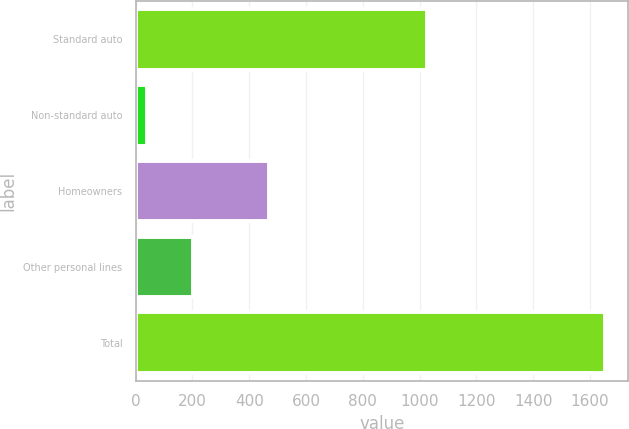Convert chart. <chart><loc_0><loc_0><loc_500><loc_500><bar_chart><fcel>Standard auto<fcel>Non-standard auto<fcel>Homeowners<fcel>Other personal lines<fcel>Total<nl><fcel>1025<fcel>40<fcel>471<fcel>201.1<fcel>1651<nl></chart> 